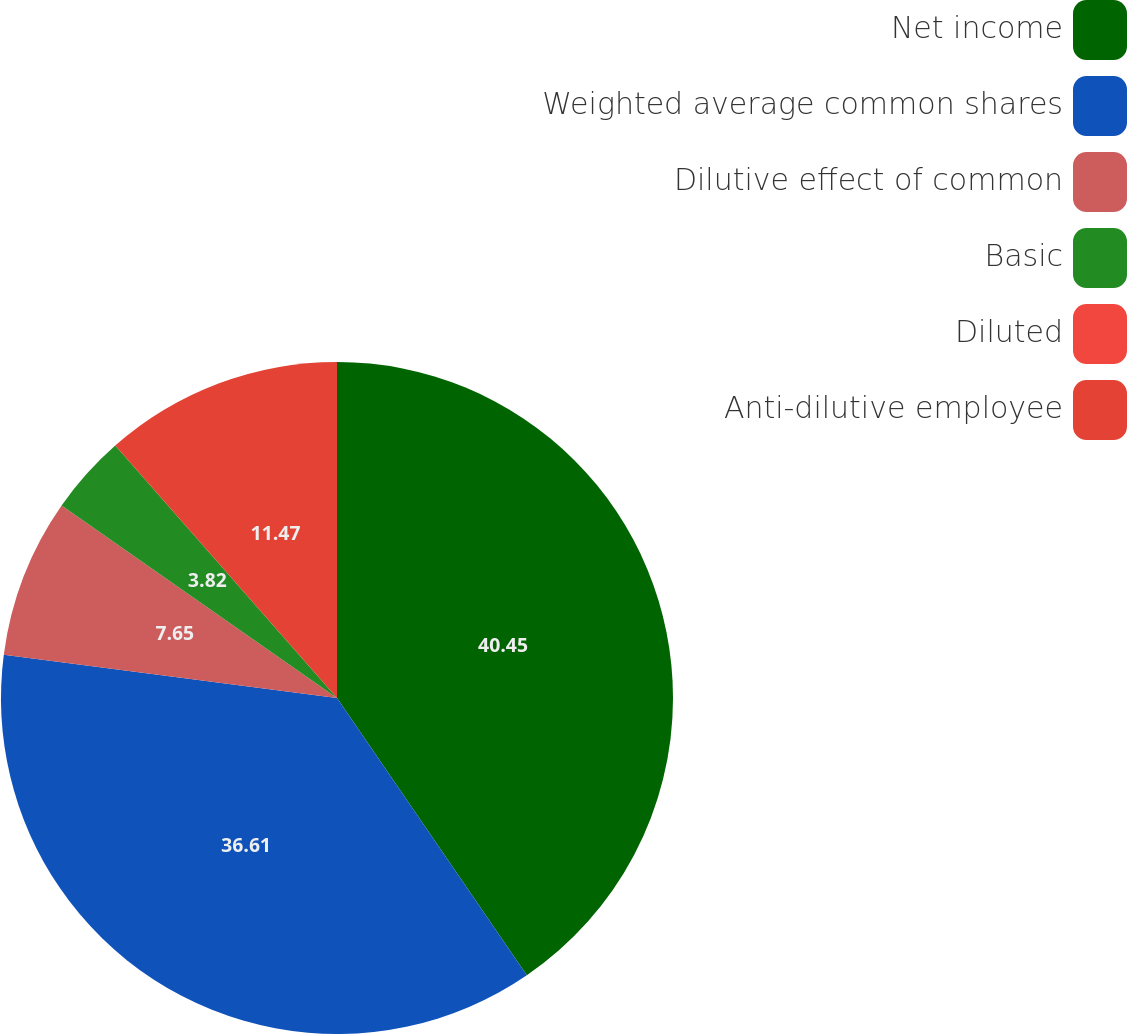Convert chart to OTSL. <chart><loc_0><loc_0><loc_500><loc_500><pie_chart><fcel>Net income<fcel>Weighted average common shares<fcel>Dilutive effect of common<fcel>Basic<fcel>Diluted<fcel>Anti-dilutive employee<nl><fcel>40.44%<fcel>36.61%<fcel>7.65%<fcel>3.82%<fcel>0.0%<fcel>11.47%<nl></chart> 